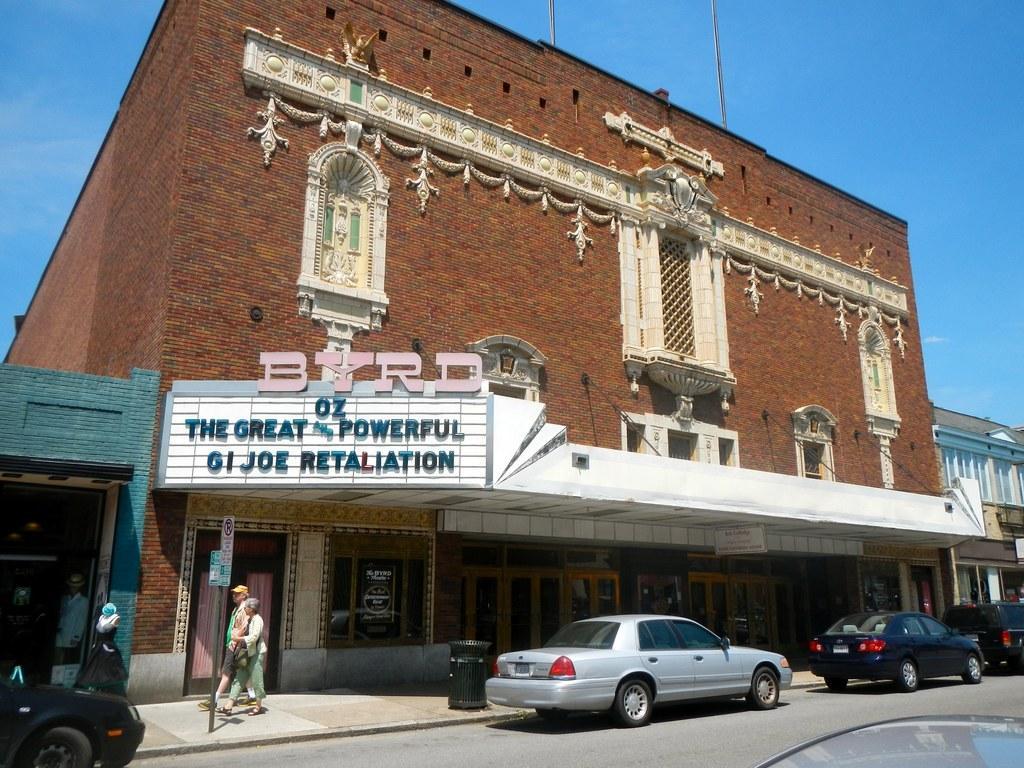Could you give a brief overview of what you see in this image? This picture is clicked outside. In the foreground we can see the cars and the group of persons and we can see the buildings and the text on the boards attached to the building. In the background we can see the sky and we can see the curtains and many other objects. 